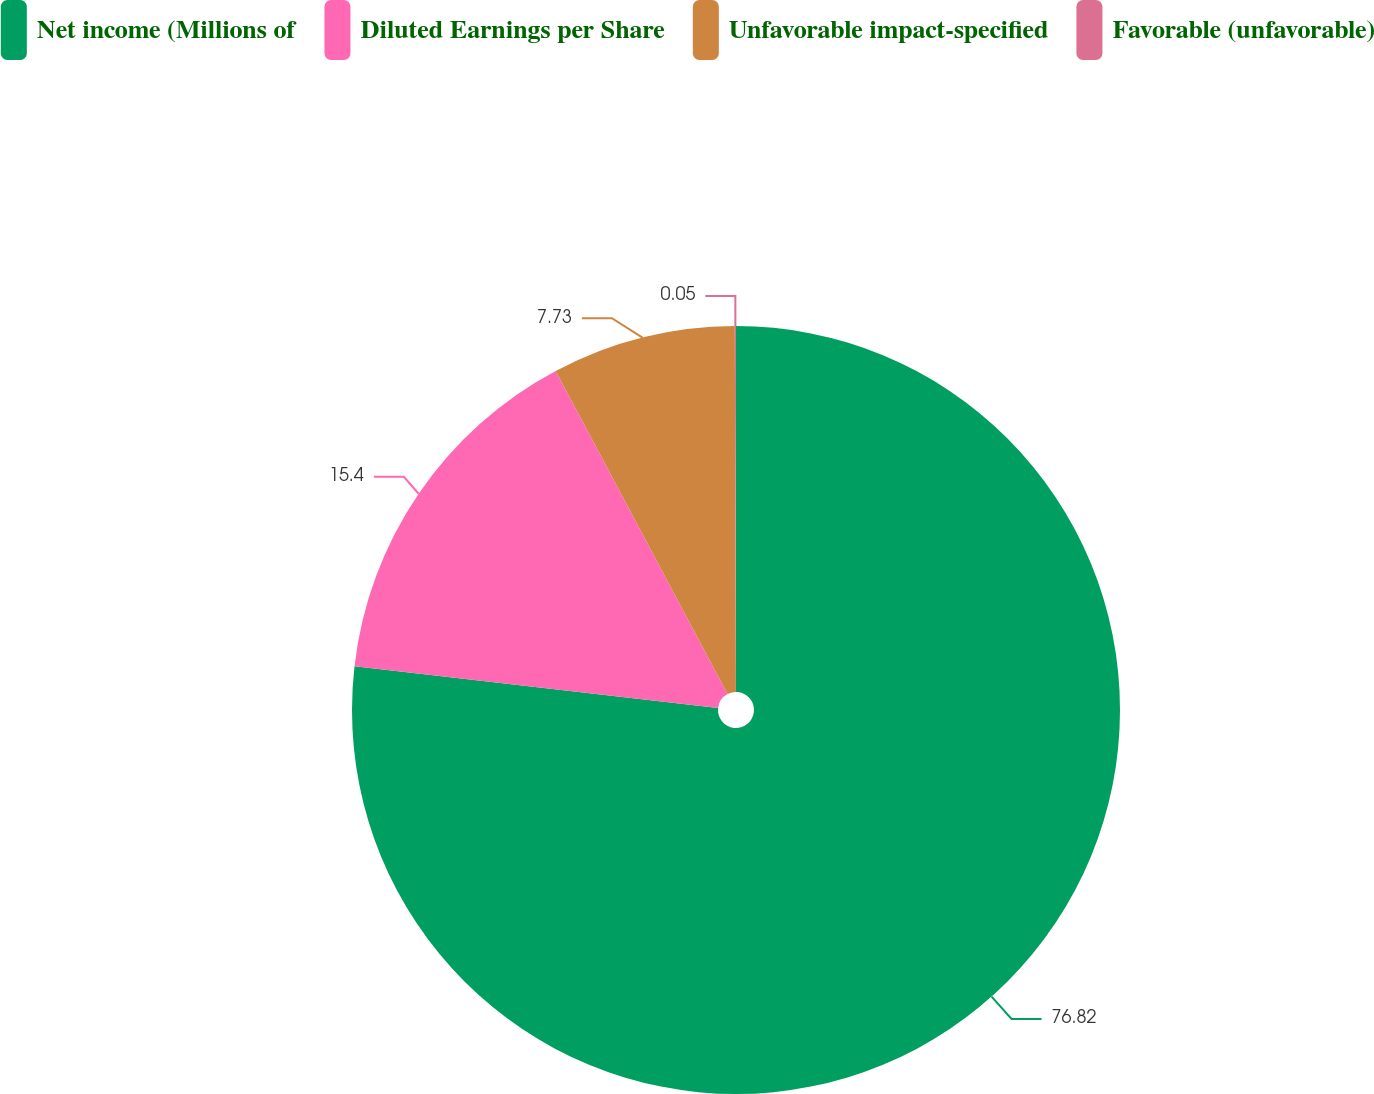Convert chart. <chart><loc_0><loc_0><loc_500><loc_500><pie_chart><fcel>Net income (Millions of<fcel>Diluted Earnings per Share<fcel>Unfavorable impact-specified<fcel>Favorable (unfavorable)<nl><fcel>76.82%<fcel>15.4%<fcel>7.73%<fcel>0.05%<nl></chart> 